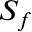Convert formula to latex. <formula><loc_0><loc_0><loc_500><loc_500>S _ { f }</formula> 